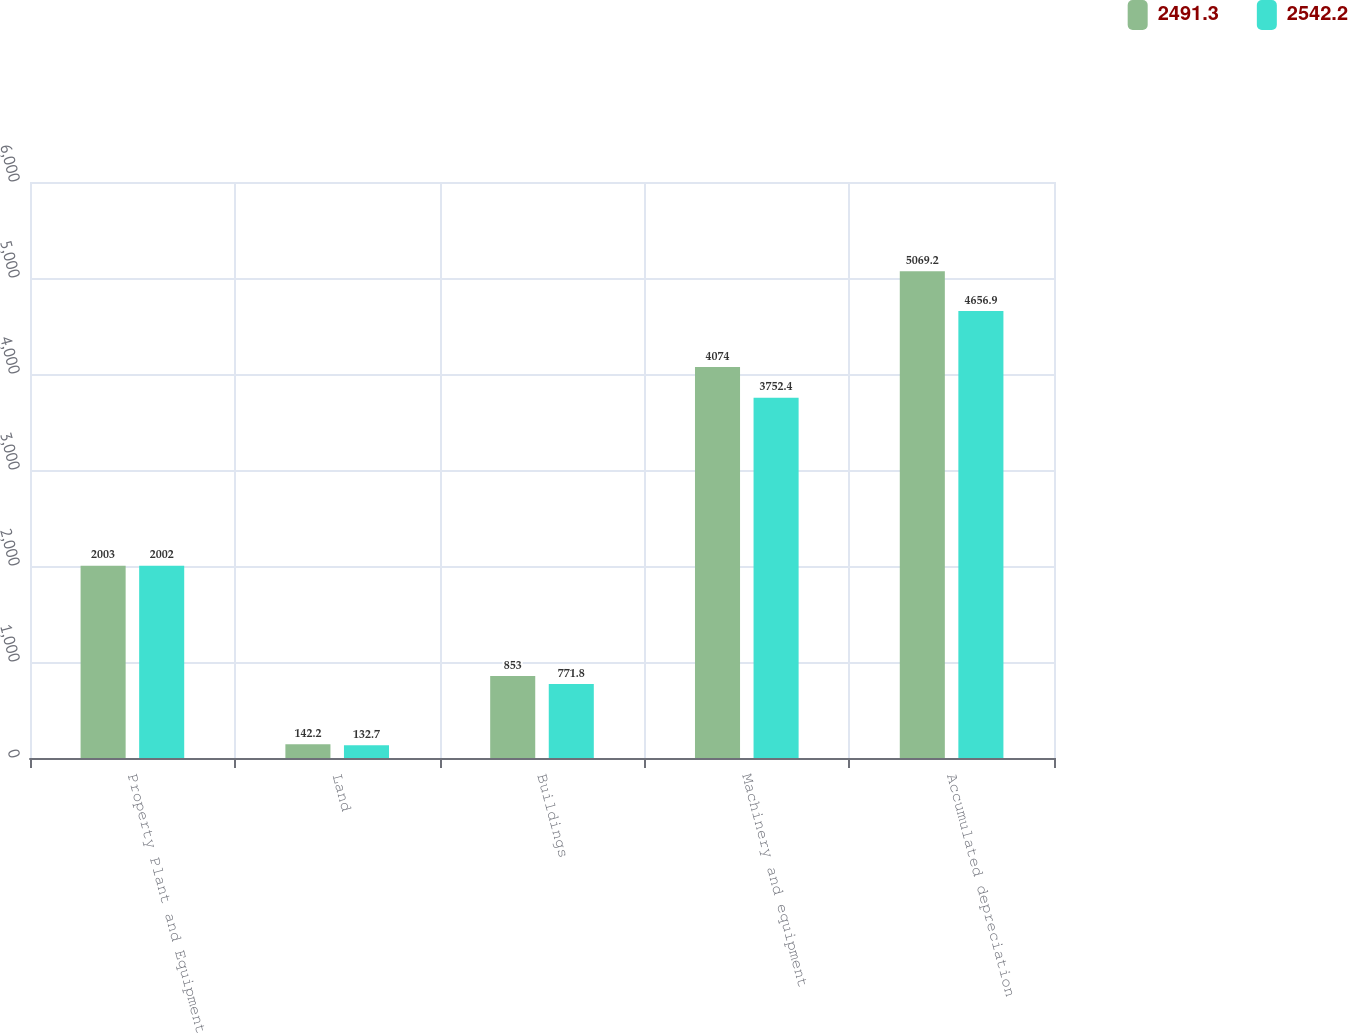Convert chart to OTSL. <chart><loc_0><loc_0><loc_500><loc_500><stacked_bar_chart><ecel><fcel>Property Plant and Equipment<fcel>Land<fcel>Buildings<fcel>Machinery and equipment<fcel>Accumulated depreciation<nl><fcel>2491.3<fcel>2003<fcel>142.2<fcel>853<fcel>4074<fcel>5069.2<nl><fcel>2542.2<fcel>2002<fcel>132.7<fcel>771.8<fcel>3752.4<fcel>4656.9<nl></chart> 